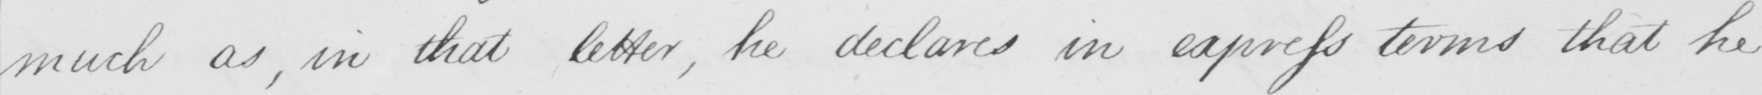Please provide the text content of this handwritten line. much as , in that letter , he declares in express terms that he 